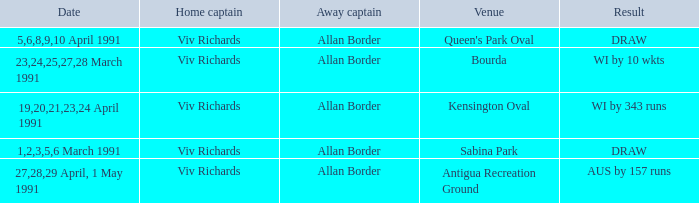What dates contained matches at the venue Bourda? 23,24,25,27,28 March 1991. 